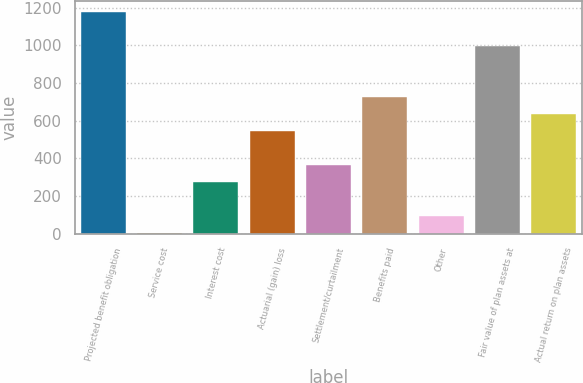<chart> <loc_0><loc_0><loc_500><loc_500><bar_chart><fcel>Projected benefit obligation<fcel>Service cost<fcel>Interest cost<fcel>Actuarial (gain) loss<fcel>Settlement/curtailment<fcel>Benefits paid<fcel>Other<fcel>Fair value of plan assets at<fcel>Actual return on plan assets<nl><fcel>1177.68<fcel>4.3<fcel>275.08<fcel>545.86<fcel>365.34<fcel>726.38<fcel>94.56<fcel>997.16<fcel>636.12<nl></chart> 